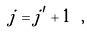<formula> <loc_0><loc_0><loc_500><loc_500>j = j ^ { \prime } + 1 \ ,</formula> 